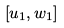<formula> <loc_0><loc_0><loc_500><loc_500>[ u _ { 1 } , w _ { 1 } ]</formula> 